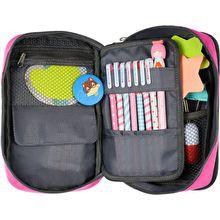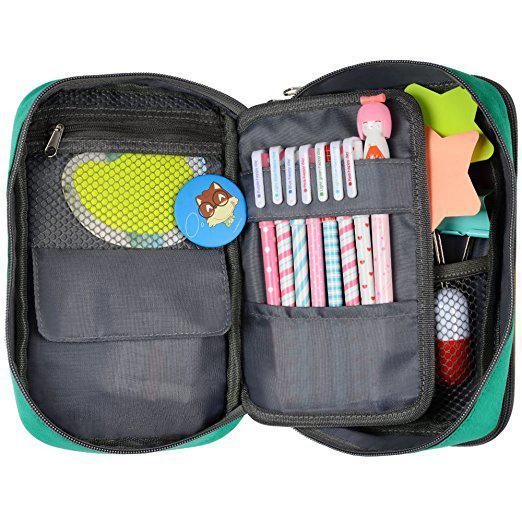The first image is the image on the left, the second image is the image on the right. For the images displayed, is the sentence "Both cases are open to reveal their contents." factually correct? Answer yes or no. Yes. The first image is the image on the left, the second image is the image on the right. Assess this claim about the two images: "Each image shows an open pencil case containing a row of writing implements in a pouch.". Correct or not? Answer yes or no. Yes. 